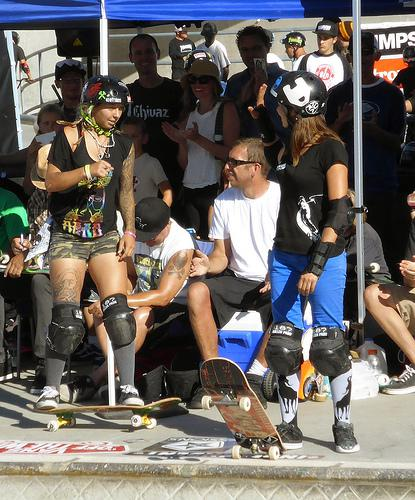Question: where was the photo taken?
Choices:
A. At the soccer game.
B. At the cheerleading tryouts.
C. At the end of the driveway.
D. At a skateboarding event.
Answer with the letter. Answer: D Question: what are the people wearing?
Choices:
A. Clothes.
B. Paper bags.
C. Cardboard.
D. Toilet paper.
Answer with the letter. Answer: A 